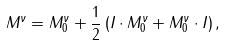<formula> <loc_0><loc_0><loc_500><loc_500>M ^ { \nu } = M ^ { \nu } _ { 0 } + \frac { 1 } { 2 } \left ( I \cdot M ^ { \nu } _ { 0 } + M ^ { \nu } _ { 0 } \cdot I \right ) ,</formula> 